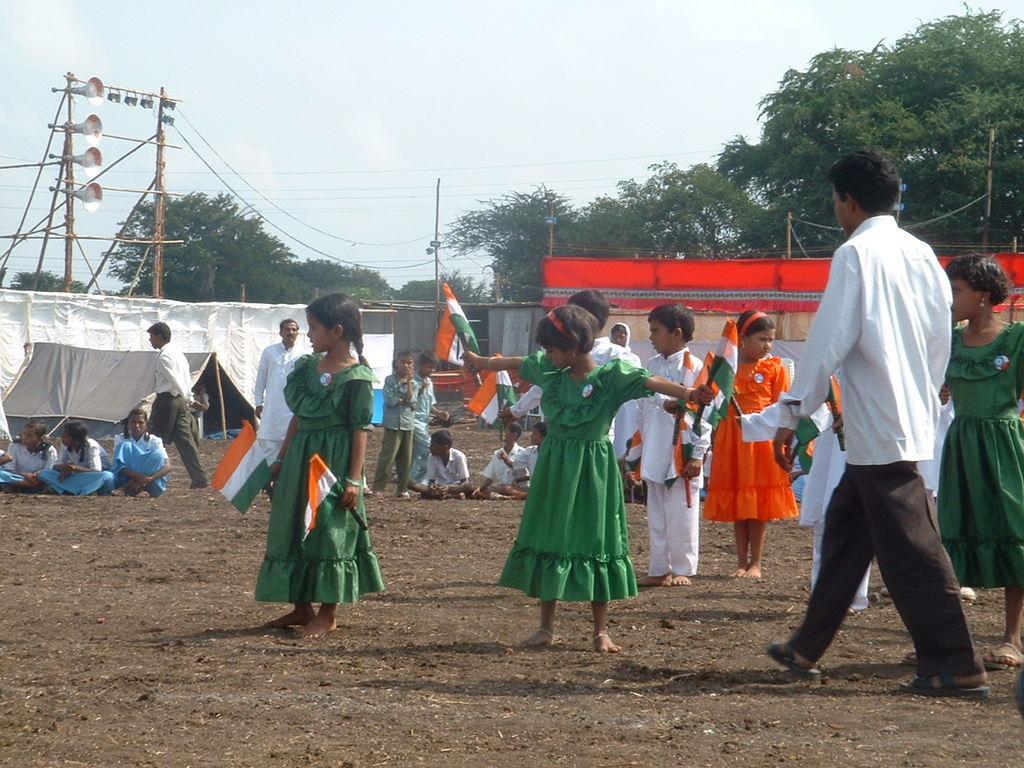How would you summarize this image in a sentence or two? In this picture we can see a group of people on the ground and few people are standing and few people are sitting, here we can see flags and in the background we can see a shed, tents, poles, loudspeakers, trees and the sky. 